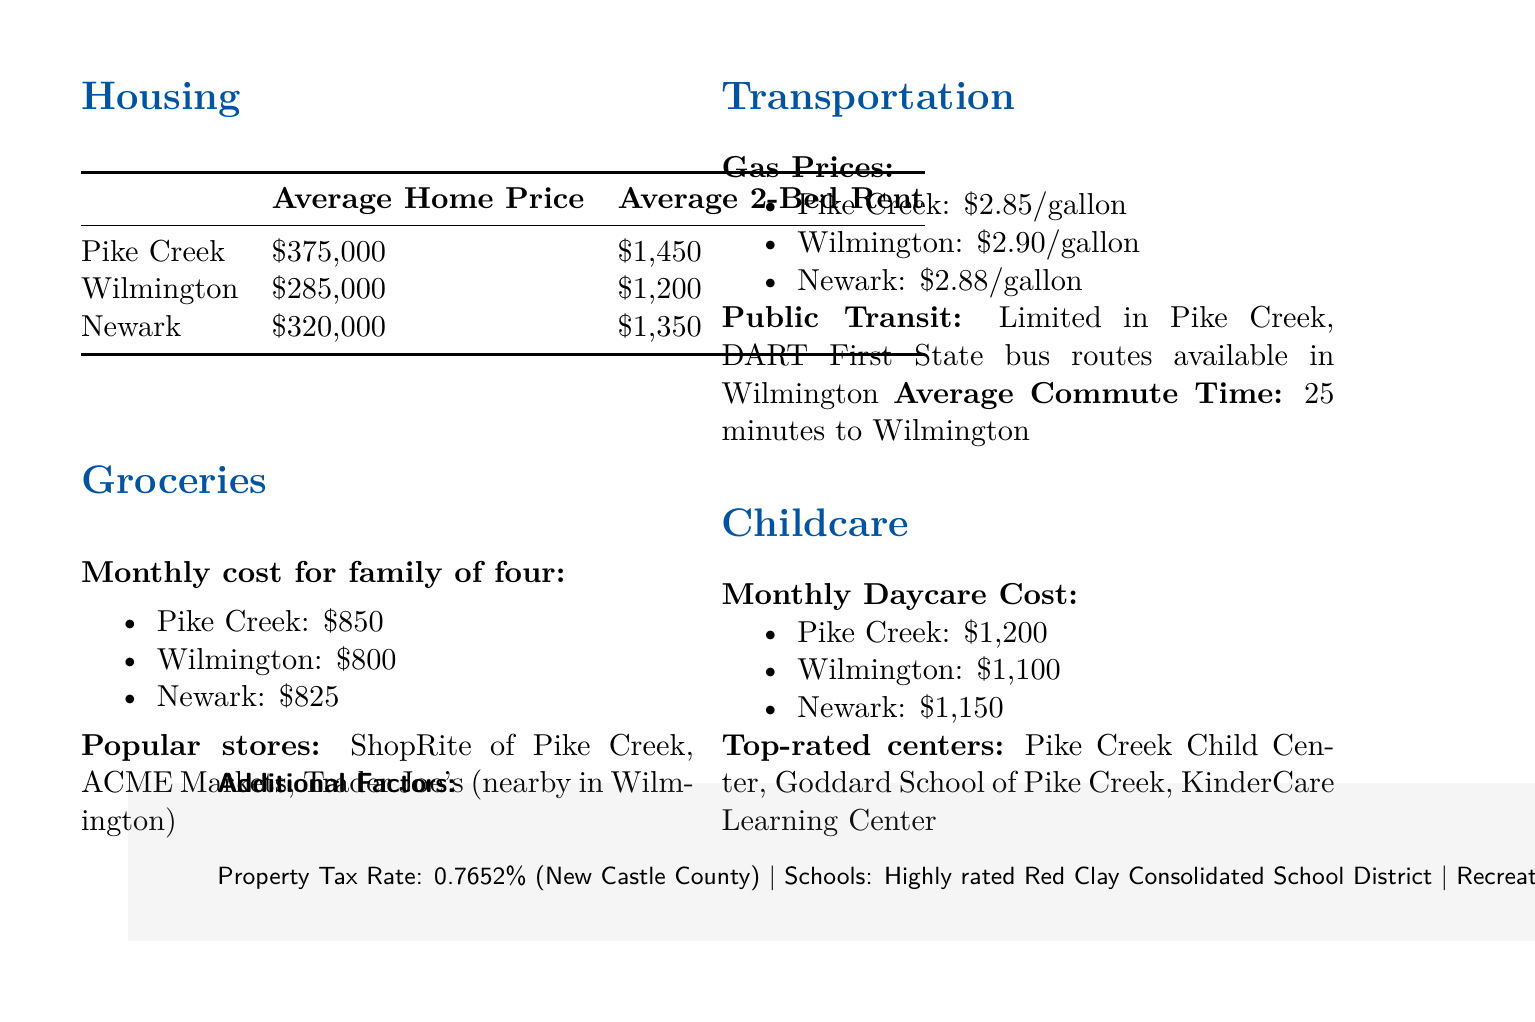What is the average home price in Pike Creek? The average home price for Pike Creek is specified in the housing section of the document.
Answer: $375,000 What is the average rent for a two-bedroom in Wilmington? The average rent for a two-bedroom in Wilmington is provided in the housing section of the document.
Answer: $1,200 How much do groceries cost monthly for a family of four in Newark? The monthly grocery cost for a family of four is provided for each area in the groceries section of the document.
Answer: $825 What are the gas prices in Pike Creek? The gas prices are detailed in the transportation section, which compares the prices across several areas.
Answer: $2.85/gallon Which childcare center is top-rated in Pike Creek? The top-rated childcare centers are listed in the childcare section of the document.
Answer: Pike Creek Child Center What is the average daycare cost in Wilmington? The average daycare cost in Wilmington can be found in the childcare section of the document.
Answer: $1,100 How does the average commute time to Wilmington from Pike Creek compare? The average commute time is provided in the transportation section and allows for a comparison of commuting from Pike Creek.
Answer: 25 minutes What is Pike Creek's property tax rate? The property tax rate is mentioned in the additional factors section of the document.
Answer: 0.7652% What is the monthly cost of groceries in Pike Creek compared to Wilmington? The monthly grocery costs for Pike Creek and Wilmington are listed, allowing for comparison.
Answer: Pike Creek: $850, Wilmington: $800 What are popular grocery stores in Pike Creek? The document lists popular grocery stores in the groceries section.
Answer: ShopRite of Pike Creek, ACME Markets, Trader Joe's 